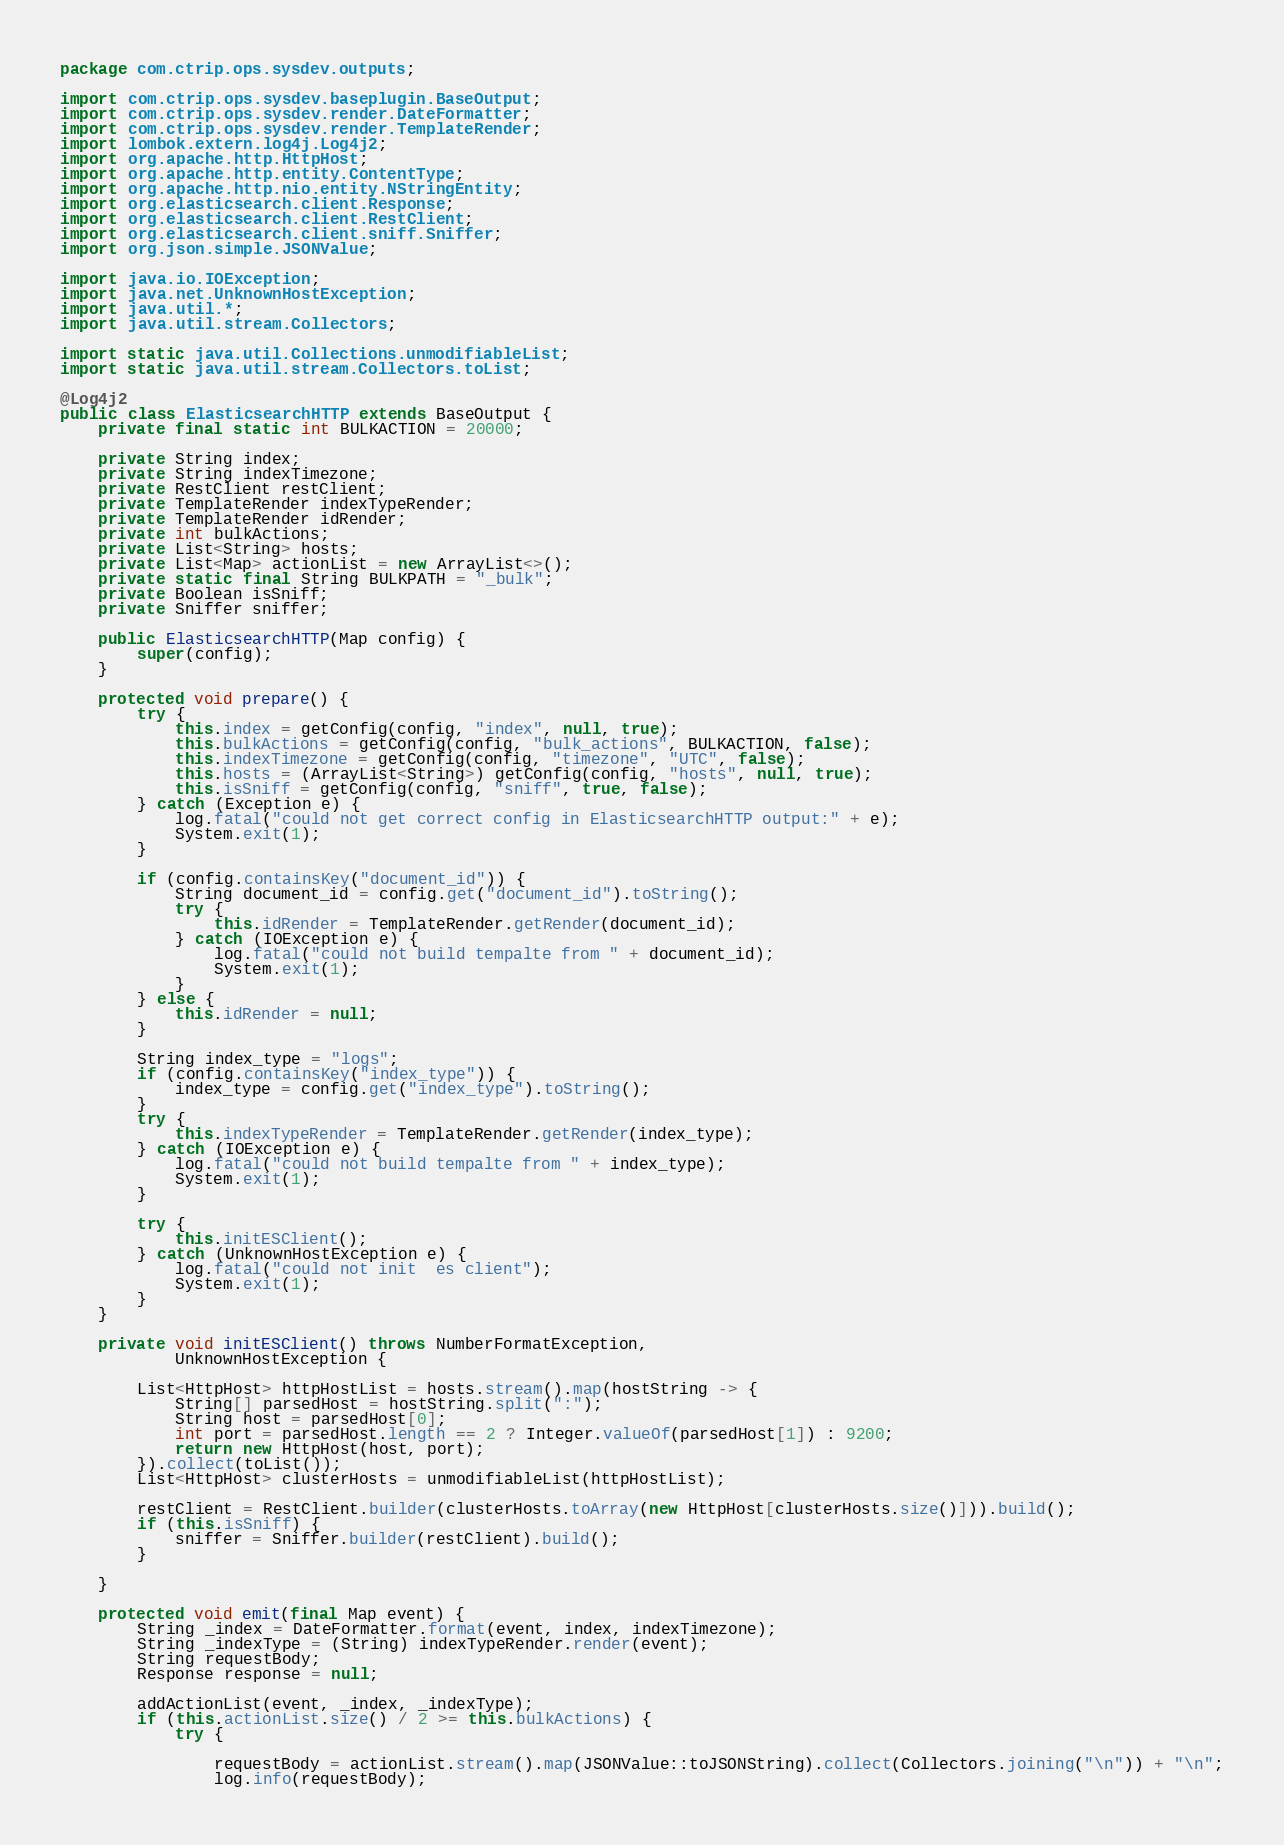<code> <loc_0><loc_0><loc_500><loc_500><_Java_>package com.ctrip.ops.sysdev.outputs;

import com.ctrip.ops.sysdev.baseplugin.BaseOutput;
import com.ctrip.ops.sysdev.render.DateFormatter;
import com.ctrip.ops.sysdev.render.TemplateRender;
import lombok.extern.log4j.Log4j2;
import org.apache.http.HttpHost;
import org.apache.http.entity.ContentType;
import org.apache.http.nio.entity.NStringEntity;
import org.elasticsearch.client.Response;
import org.elasticsearch.client.RestClient;
import org.elasticsearch.client.sniff.Sniffer;
import org.json.simple.JSONValue;

import java.io.IOException;
import java.net.UnknownHostException;
import java.util.*;
import java.util.stream.Collectors;

import static java.util.Collections.unmodifiableList;
import static java.util.stream.Collectors.toList;

@Log4j2
public class ElasticsearchHTTP extends BaseOutput {
    private final static int BULKACTION = 20000;

    private String index;
    private String indexTimezone;
    private RestClient restClient;
    private TemplateRender indexTypeRender;
    private TemplateRender idRender;
    private int bulkActions;
    private List<String> hosts;
    private List<Map> actionList = new ArrayList<>();
    private static final String BULKPATH = "_bulk";
    private Boolean isSniff;
    private Sniffer sniffer;

    public ElasticsearchHTTP(Map config) {
        super(config);
    }

    protected void prepare() {
        try {
            this.index = getConfig(config, "index", null, true);
            this.bulkActions = getConfig(config, "bulk_actions", BULKACTION, false);
            this.indexTimezone = getConfig(config, "timezone", "UTC", false);
            this.hosts = (ArrayList<String>) getConfig(config, "hosts", null, true);
            this.isSniff = getConfig(config, "sniff", true, false);
        } catch (Exception e) {
            log.fatal("could not get correct config in ElasticsearchHTTP output:" + e);
            System.exit(1);
        }

        if (config.containsKey("document_id")) {
            String document_id = config.get("document_id").toString();
            try {
                this.idRender = TemplateRender.getRender(document_id);
            } catch (IOException e) {
                log.fatal("could not build tempalte from " + document_id);
                System.exit(1);
            }
        } else {
            this.idRender = null;
        }

        String index_type = "logs";
        if (config.containsKey("index_type")) {
            index_type = config.get("index_type").toString();
        }
        try {
            this.indexTypeRender = TemplateRender.getRender(index_type);
        } catch (IOException e) {
            log.fatal("could not build tempalte from " + index_type);
            System.exit(1);
        }

        try {
            this.initESClient();
        } catch (UnknownHostException e) {
            log.fatal("could not init  es client");
            System.exit(1);
        }
    }

    private void initESClient() throws NumberFormatException,
            UnknownHostException {

        List<HttpHost> httpHostList = hosts.stream().map(hostString -> {
            String[] parsedHost = hostString.split(":");
            String host = parsedHost[0];
            int port = parsedHost.length == 2 ? Integer.valueOf(parsedHost[1]) : 9200;
            return new HttpHost(host, port);
        }).collect(toList());
        List<HttpHost> clusterHosts = unmodifiableList(httpHostList);

        restClient = RestClient.builder(clusterHosts.toArray(new HttpHost[clusterHosts.size()])).build();
        if (this.isSniff) {
            sniffer = Sniffer.builder(restClient).build();
        }

    }

    protected void emit(final Map event) {
        String _index = DateFormatter.format(event, index, indexTimezone);
        String _indexType = (String) indexTypeRender.render(event);
        String requestBody;
        Response response = null;

        addActionList(event, _index, _indexType);
        if (this.actionList.size() / 2 >= this.bulkActions) {
            try {

                requestBody = actionList.stream().map(JSONValue::toJSONString).collect(Collectors.joining("\n")) + "\n";
                log.info(requestBody);</code> 